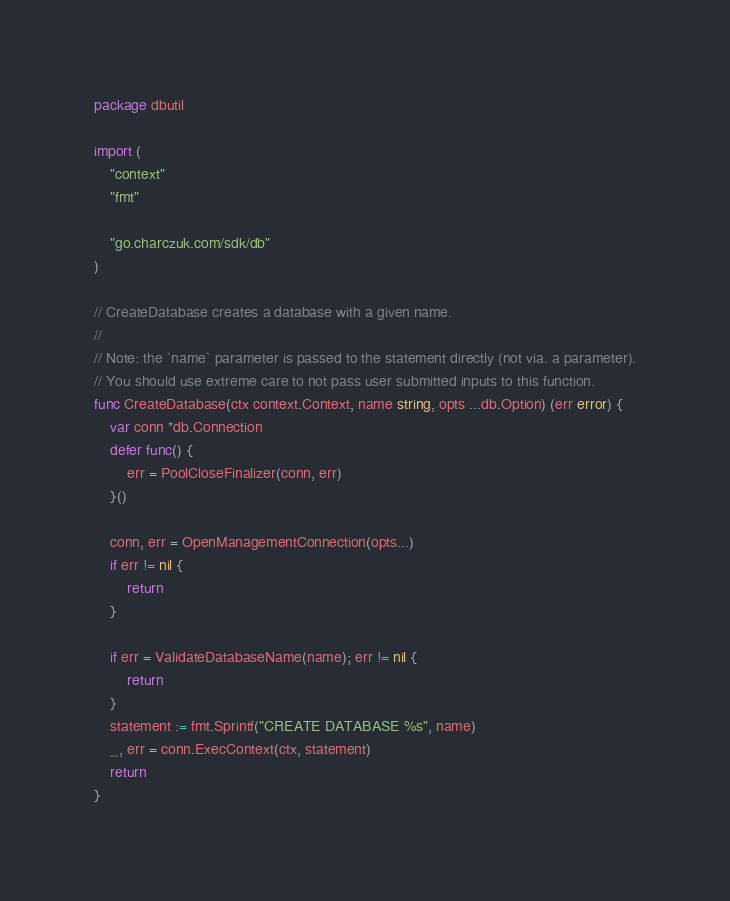Convert code to text. <code><loc_0><loc_0><loc_500><loc_500><_Go_>package dbutil

import (
	"context"
	"fmt"

	"go.charczuk.com/sdk/db"
)

// CreateDatabase creates a database with a given name.
//
// Note: the `name` parameter is passed to the statement directly (not via. a parameter).
// You should use extreme care to not pass user submitted inputs to this function.
func CreateDatabase(ctx context.Context, name string, opts ...db.Option) (err error) {
	var conn *db.Connection
	defer func() {
		err = PoolCloseFinalizer(conn, err)
	}()

	conn, err = OpenManagementConnection(opts...)
	if err != nil {
		return
	}

	if err = ValidateDatabaseName(name); err != nil {
		return
	}
	statement := fmt.Sprintf("CREATE DATABASE %s", name)
	_, err = conn.ExecContext(ctx, statement)
	return
}
</code> 